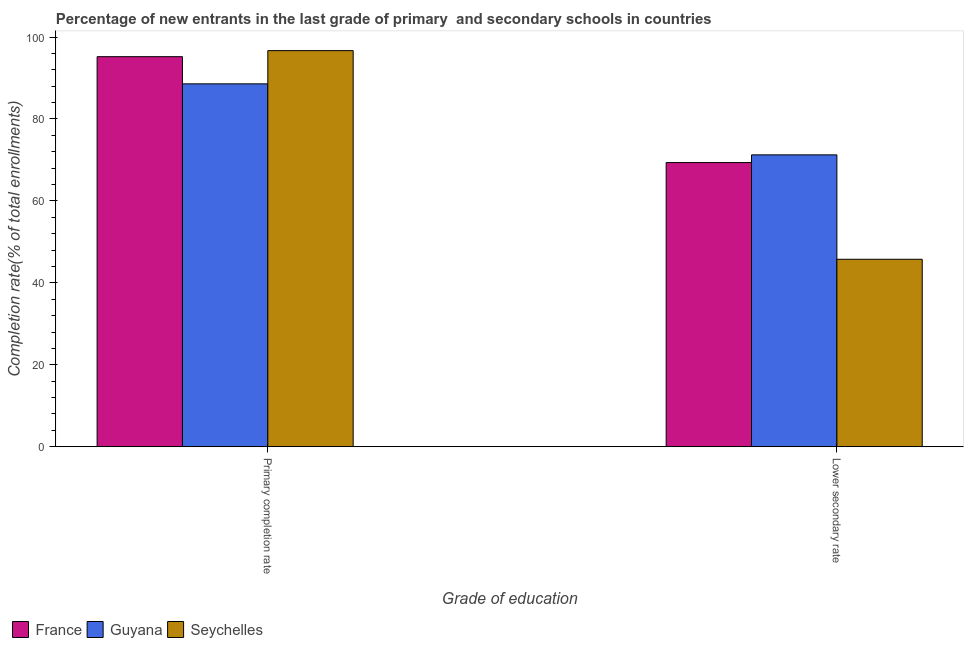Are the number of bars on each tick of the X-axis equal?
Keep it short and to the point. Yes. How many bars are there on the 2nd tick from the left?
Provide a short and direct response. 3. What is the label of the 2nd group of bars from the left?
Give a very brief answer. Lower secondary rate. What is the completion rate in primary schools in Seychelles?
Your answer should be compact. 96.68. Across all countries, what is the maximum completion rate in primary schools?
Your answer should be compact. 96.68. Across all countries, what is the minimum completion rate in secondary schools?
Keep it short and to the point. 45.75. In which country was the completion rate in primary schools maximum?
Ensure brevity in your answer.  Seychelles. In which country was the completion rate in primary schools minimum?
Provide a short and direct response. Guyana. What is the total completion rate in primary schools in the graph?
Offer a terse response. 280.46. What is the difference between the completion rate in secondary schools in Guyana and that in Seychelles?
Your response must be concise. 25.48. What is the difference between the completion rate in primary schools in Guyana and the completion rate in secondary schools in France?
Your response must be concise. 19.21. What is the average completion rate in secondary schools per country?
Offer a terse response. 62.12. What is the difference between the completion rate in secondary schools and completion rate in primary schools in Guyana?
Provide a succinct answer. -17.34. In how many countries, is the completion rate in secondary schools greater than 32 %?
Your answer should be compact. 3. What is the ratio of the completion rate in secondary schools in Seychelles to that in France?
Your answer should be very brief. 0.66. Is the completion rate in primary schools in Guyana less than that in France?
Provide a short and direct response. Yes. What does the 2nd bar from the left in Primary completion rate represents?
Provide a short and direct response. Guyana. What does the 3rd bar from the right in Lower secondary rate represents?
Your answer should be very brief. France. How are the legend labels stacked?
Provide a short and direct response. Horizontal. What is the title of the graph?
Make the answer very short. Percentage of new entrants in the last grade of primary  and secondary schools in countries. What is the label or title of the X-axis?
Give a very brief answer. Grade of education. What is the label or title of the Y-axis?
Make the answer very short. Completion rate(% of total enrollments). What is the Completion rate(% of total enrollments) of France in Primary completion rate?
Give a very brief answer. 95.21. What is the Completion rate(% of total enrollments) in Guyana in Primary completion rate?
Provide a succinct answer. 88.57. What is the Completion rate(% of total enrollments) of Seychelles in Primary completion rate?
Provide a succinct answer. 96.68. What is the Completion rate(% of total enrollments) in France in Lower secondary rate?
Your answer should be very brief. 69.36. What is the Completion rate(% of total enrollments) in Guyana in Lower secondary rate?
Provide a short and direct response. 71.24. What is the Completion rate(% of total enrollments) of Seychelles in Lower secondary rate?
Provide a short and direct response. 45.75. Across all Grade of education, what is the maximum Completion rate(% of total enrollments) in France?
Provide a short and direct response. 95.21. Across all Grade of education, what is the maximum Completion rate(% of total enrollments) of Guyana?
Provide a succinct answer. 88.57. Across all Grade of education, what is the maximum Completion rate(% of total enrollments) of Seychelles?
Offer a very short reply. 96.68. Across all Grade of education, what is the minimum Completion rate(% of total enrollments) in France?
Your answer should be compact. 69.36. Across all Grade of education, what is the minimum Completion rate(% of total enrollments) of Guyana?
Give a very brief answer. 71.24. Across all Grade of education, what is the minimum Completion rate(% of total enrollments) of Seychelles?
Provide a short and direct response. 45.75. What is the total Completion rate(% of total enrollments) in France in the graph?
Your answer should be very brief. 164.57. What is the total Completion rate(% of total enrollments) of Guyana in the graph?
Provide a short and direct response. 159.81. What is the total Completion rate(% of total enrollments) of Seychelles in the graph?
Keep it short and to the point. 142.44. What is the difference between the Completion rate(% of total enrollments) in France in Primary completion rate and that in Lower secondary rate?
Your answer should be compact. 25.85. What is the difference between the Completion rate(% of total enrollments) in Guyana in Primary completion rate and that in Lower secondary rate?
Offer a terse response. 17.34. What is the difference between the Completion rate(% of total enrollments) in Seychelles in Primary completion rate and that in Lower secondary rate?
Your answer should be compact. 50.93. What is the difference between the Completion rate(% of total enrollments) of France in Primary completion rate and the Completion rate(% of total enrollments) of Guyana in Lower secondary rate?
Ensure brevity in your answer.  23.97. What is the difference between the Completion rate(% of total enrollments) of France in Primary completion rate and the Completion rate(% of total enrollments) of Seychelles in Lower secondary rate?
Offer a very short reply. 49.45. What is the difference between the Completion rate(% of total enrollments) in Guyana in Primary completion rate and the Completion rate(% of total enrollments) in Seychelles in Lower secondary rate?
Make the answer very short. 42.82. What is the average Completion rate(% of total enrollments) in France per Grade of education?
Offer a terse response. 82.28. What is the average Completion rate(% of total enrollments) in Guyana per Grade of education?
Give a very brief answer. 79.91. What is the average Completion rate(% of total enrollments) of Seychelles per Grade of education?
Your answer should be very brief. 71.22. What is the difference between the Completion rate(% of total enrollments) of France and Completion rate(% of total enrollments) of Guyana in Primary completion rate?
Your answer should be compact. 6.63. What is the difference between the Completion rate(% of total enrollments) in France and Completion rate(% of total enrollments) in Seychelles in Primary completion rate?
Ensure brevity in your answer.  -1.48. What is the difference between the Completion rate(% of total enrollments) in Guyana and Completion rate(% of total enrollments) in Seychelles in Primary completion rate?
Make the answer very short. -8.11. What is the difference between the Completion rate(% of total enrollments) in France and Completion rate(% of total enrollments) in Guyana in Lower secondary rate?
Your answer should be compact. -1.88. What is the difference between the Completion rate(% of total enrollments) in France and Completion rate(% of total enrollments) in Seychelles in Lower secondary rate?
Make the answer very short. 23.61. What is the difference between the Completion rate(% of total enrollments) of Guyana and Completion rate(% of total enrollments) of Seychelles in Lower secondary rate?
Give a very brief answer. 25.48. What is the ratio of the Completion rate(% of total enrollments) in France in Primary completion rate to that in Lower secondary rate?
Offer a very short reply. 1.37. What is the ratio of the Completion rate(% of total enrollments) of Guyana in Primary completion rate to that in Lower secondary rate?
Keep it short and to the point. 1.24. What is the ratio of the Completion rate(% of total enrollments) of Seychelles in Primary completion rate to that in Lower secondary rate?
Give a very brief answer. 2.11. What is the difference between the highest and the second highest Completion rate(% of total enrollments) in France?
Make the answer very short. 25.85. What is the difference between the highest and the second highest Completion rate(% of total enrollments) in Guyana?
Make the answer very short. 17.34. What is the difference between the highest and the second highest Completion rate(% of total enrollments) in Seychelles?
Offer a terse response. 50.93. What is the difference between the highest and the lowest Completion rate(% of total enrollments) in France?
Your answer should be very brief. 25.85. What is the difference between the highest and the lowest Completion rate(% of total enrollments) of Guyana?
Give a very brief answer. 17.34. What is the difference between the highest and the lowest Completion rate(% of total enrollments) in Seychelles?
Your response must be concise. 50.93. 